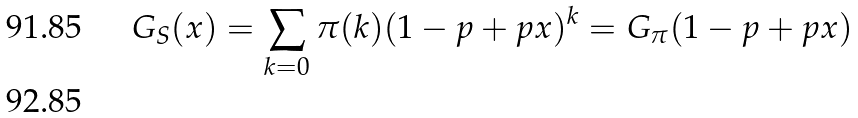<formula> <loc_0><loc_0><loc_500><loc_500>G _ { S } ( x ) = \sum _ { k = 0 } \pi ( k ) ( 1 - p + p x ) ^ { k } = G _ { \pi } ( 1 - p + p x ) \\</formula> 